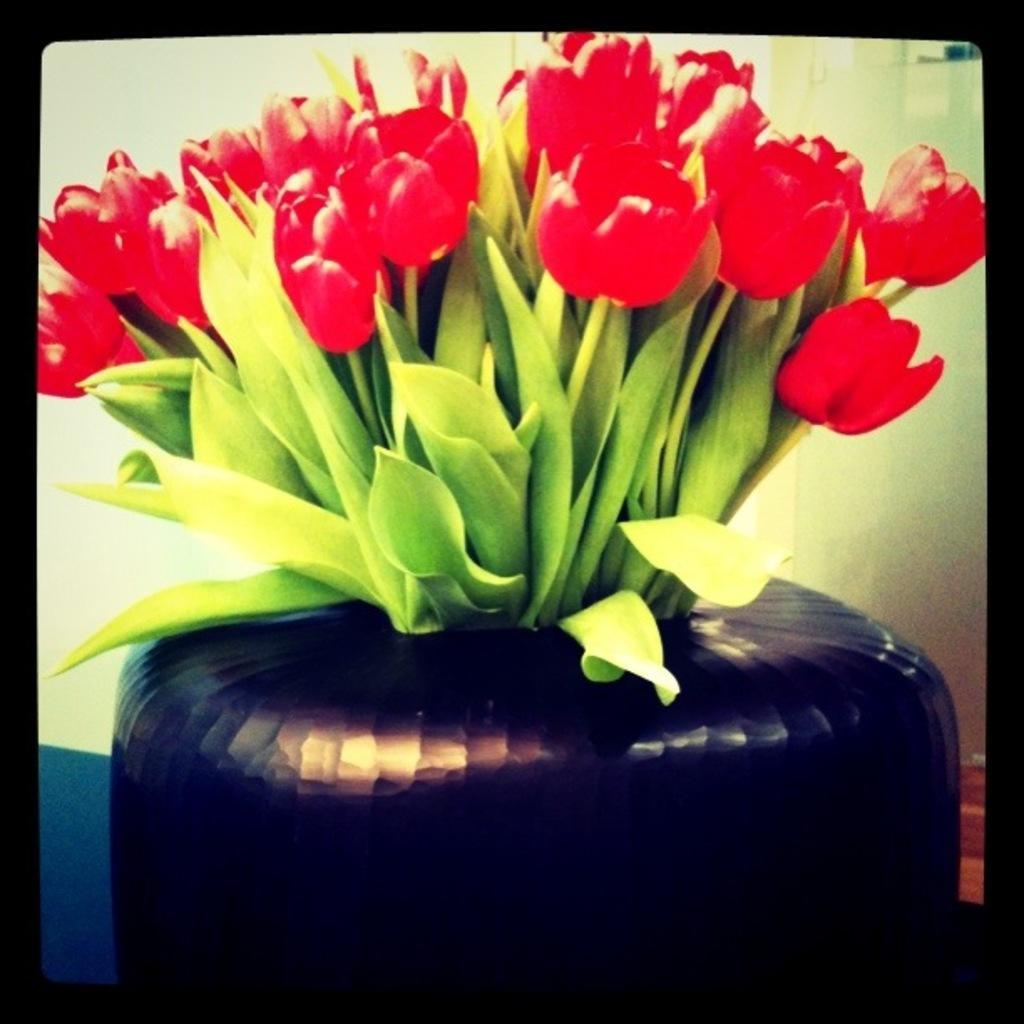Can you describe this image briefly? The picture consists of a flower vase with red flowers. The picture has black border. In the background it is well. 